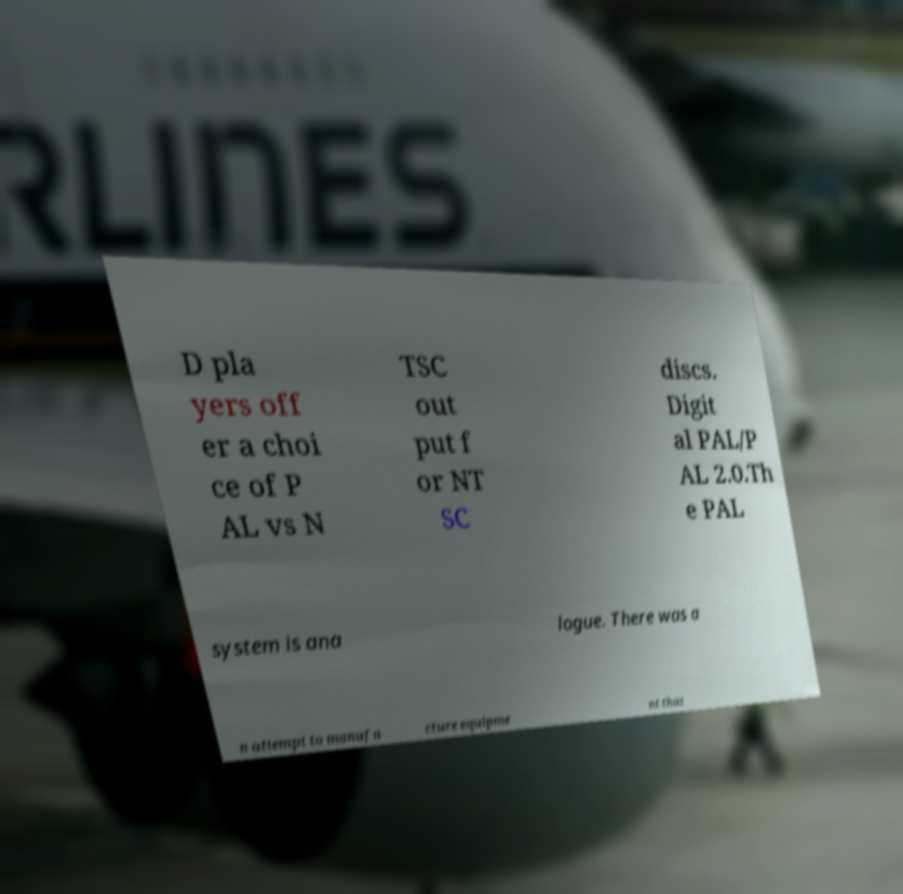Please read and relay the text visible in this image. What does it say? D pla yers off er a choi ce of P AL vs N TSC out put f or NT SC discs. Digit al PAL/P AL 2.0.Th e PAL system is ana logue. There was a n attempt to manufa cture equipme nt that 